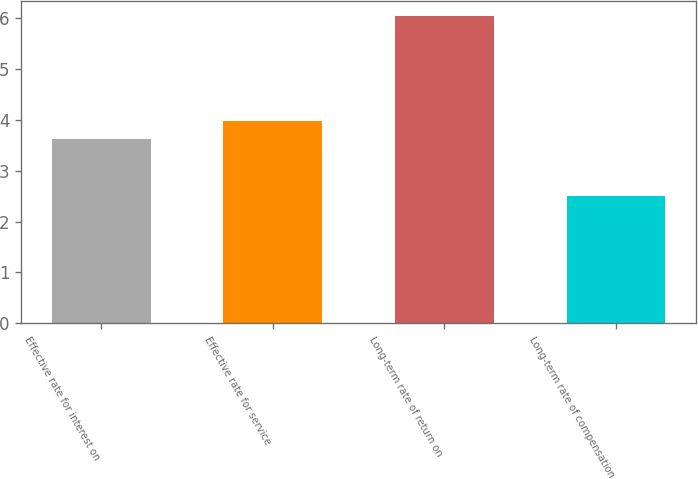Convert chart. <chart><loc_0><loc_0><loc_500><loc_500><bar_chart><fcel>Effective rate for interest on<fcel>Effective rate for service<fcel>Long-term rate of return on<fcel>Long-term rate of compensation<nl><fcel>3.63<fcel>3.98<fcel>6.04<fcel>2.5<nl></chart> 